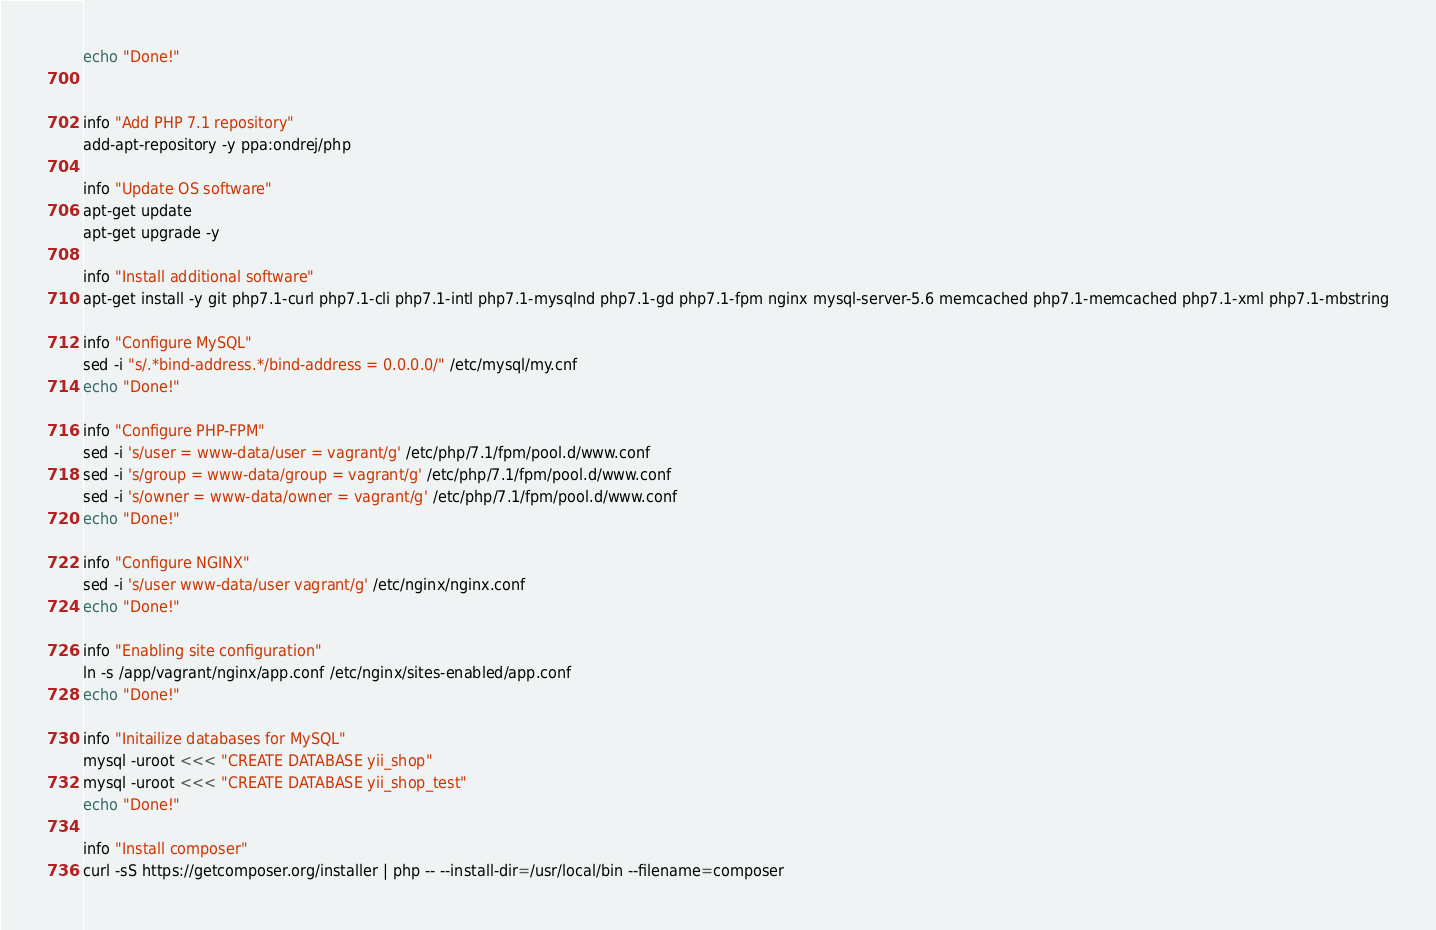Convert code to text. <code><loc_0><loc_0><loc_500><loc_500><_Bash_>echo "Done!"


info "Add PHP 7.1 repository"
add-apt-repository -y ppa:ondrej/php

info "Update OS software"
apt-get update
apt-get upgrade -y

info "Install additional software"
apt-get install -y git php7.1-curl php7.1-cli php7.1-intl php7.1-mysqlnd php7.1-gd php7.1-fpm nginx mysql-server-5.6 memcached php7.1-memcached php7.1-xml php7.1-mbstring

info "Configure MySQL"
sed -i "s/.*bind-address.*/bind-address = 0.0.0.0/" /etc/mysql/my.cnf
echo "Done!"

info "Configure PHP-FPM"
sed -i 's/user = www-data/user = vagrant/g' /etc/php/7.1/fpm/pool.d/www.conf
sed -i 's/group = www-data/group = vagrant/g' /etc/php/7.1/fpm/pool.d/www.conf
sed -i 's/owner = www-data/owner = vagrant/g' /etc/php/7.1/fpm/pool.d/www.conf
echo "Done!"

info "Configure NGINX"
sed -i 's/user www-data/user vagrant/g' /etc/nginx/nginx.conf
echo "Done!"

info "Enabling site configuration"
ln -s /app/vagrant/nginx/app.conf /etc/nginx/sites-enabled/app.conf
echo "Done!"

info "Initailize databases for MySQL"
mysql -uroot <<< "CREATE DATABASE yii_shop"
mysql -uroot <<< "CREATE DATABASE yii_shop_test"
echo "Done!"

info "Install composer"
curl -sS https://getcomposer.org/installer | php -- --install-dir=/usr/local/bin --filename=composer</code> 